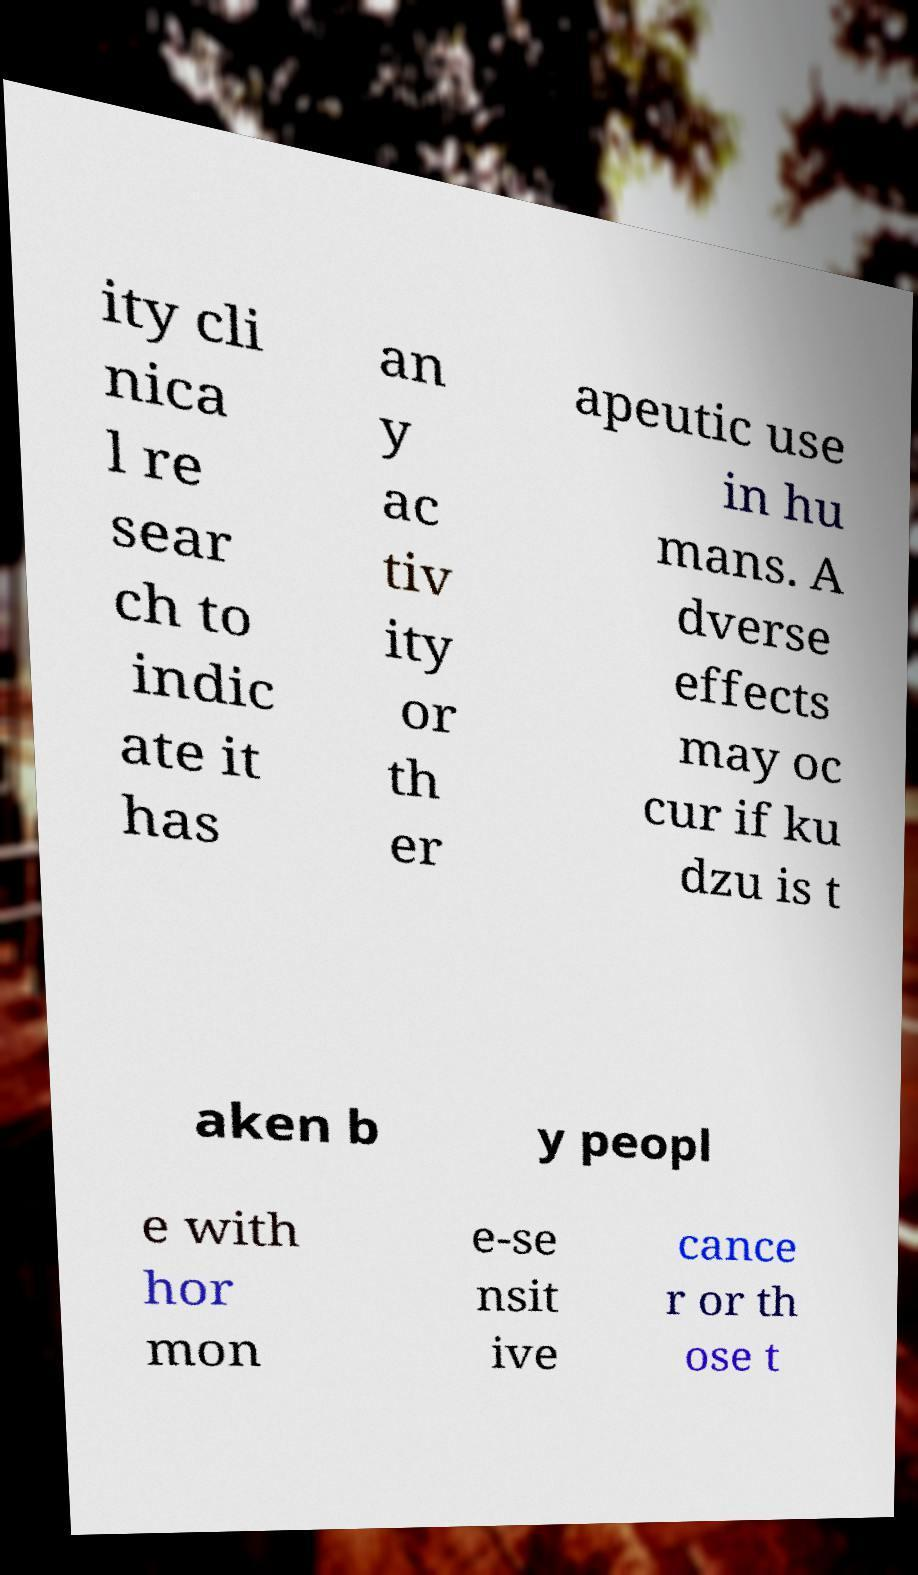There's text embedded in this image that I need extracted. Can you transcribe it verbatim? ity cli nica l re sear ch to indic ate it has an y ac tiv ity or th er apeutic use in hu mans. A dverse effects may oc cur if ku dzu is t aken b y peopl e with hor mon e-se nsit ive cance r or th ose t 